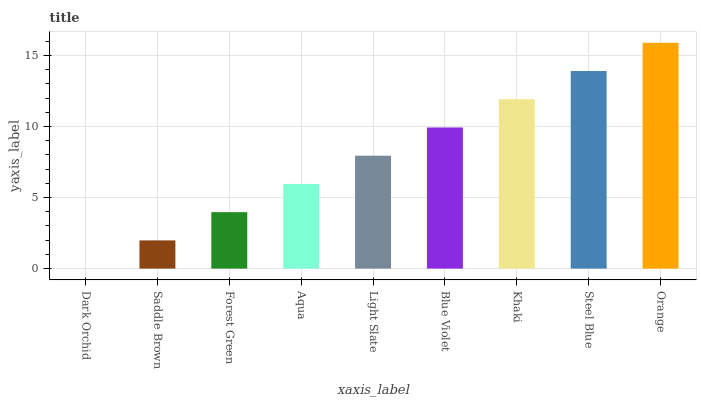Is Saddle Brown the minimum?
Answer yes or no. No. Is Saddle Brown the maximum?
Answer yes or no. No. Is Saddle Brown greater than Dark Orchid?
Answer yes or no. Yes. Is Dark Orchid less than Saddle Brown?
Answer yes or no. Yes. Is Dark Orchid greater than Saddle Brown?
Answer yes or no. No. Is Saddle Brown less than Dark Orchid?
Answer yes or no. No. Is Light Slate the high median?
Answer yes or no. Yes. Is Light Slate the low median?
Answer yes or no. Yes. Is Orange the high median?
Answer yes or no. No. Is Dark Orchid the low median?
Answer yes or no. No. 